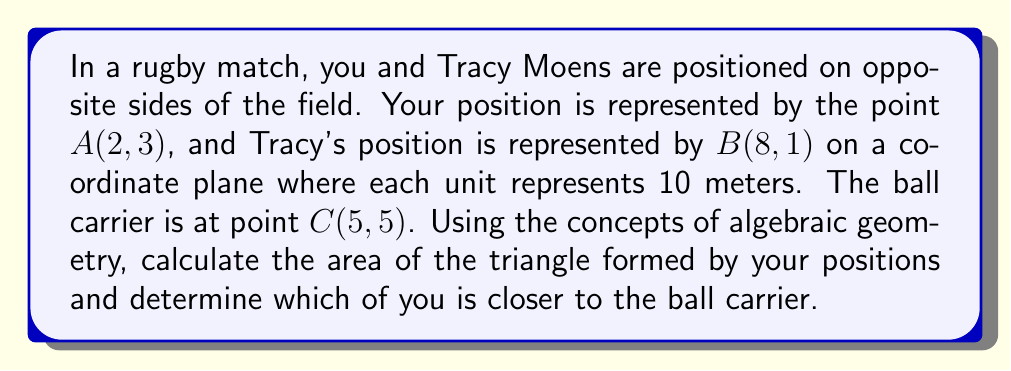Can you answer this question? Let's approach this step-by-step:

1) To find the area of the triangle, we can use the formula:
   $$\text{Area} = \frac{1}{2}|x_1(y_2 - y_3) + x_2(y_3 - y_1) + x_3(y_1 - y_2)|$$
   where $(x_1, y_1)$, $(x_2, y_2)$, and $(x_3, y_3)$ are the coordinates of the three points.

2) Substituting the given coordinates:
   $$\text{Area} = \frac{1}{2}|2(1 - 5) + 8(5 - 3) + 5(3 - 1)|$$

3) Simplifying:
   $$\text{Area} = \frac{1}{2}|2(-4) + 8(2) + 5(2)|$$
   $$\text{Area} = \frac{1}{2}|-8 + 16 + 10|$$
   $$\text{Area} = \frac{1}{2}|18|$$
   $$\text{Area} = 9$$

4) Since each unit represents 10 meters, the actual area is:
   $$9 \times 10^2 = 900 \text{ square meters}$$

5) To determine who is closer to the ball carrier, we can calculate the distance from each player to the ball using the distance formula:
   $$d = \sqrt{(x_2 - x_1)^2 + (y_2 - y_1)^2}$$

6) For you (A) to the ball carrier (C):
   $$d_{AC} = \sqrt{(5 - 2)^2 + (5 - 3)^2} = \sqrt{9 + 4} = \sqrt{13} \approx 3.61$$

7) For Tracy (B) to the ball carrier (C):
   $$d_{BC} = \sqrt{(5 - 8)^2 + (5 - 1)^2} = \sqrt{9 + 16} = 5$$

8) Since $3.61 < 5$, you are closer to the ball carrier than Tracy.
Answer: 900 square meters; you are closer to the ball carrier 